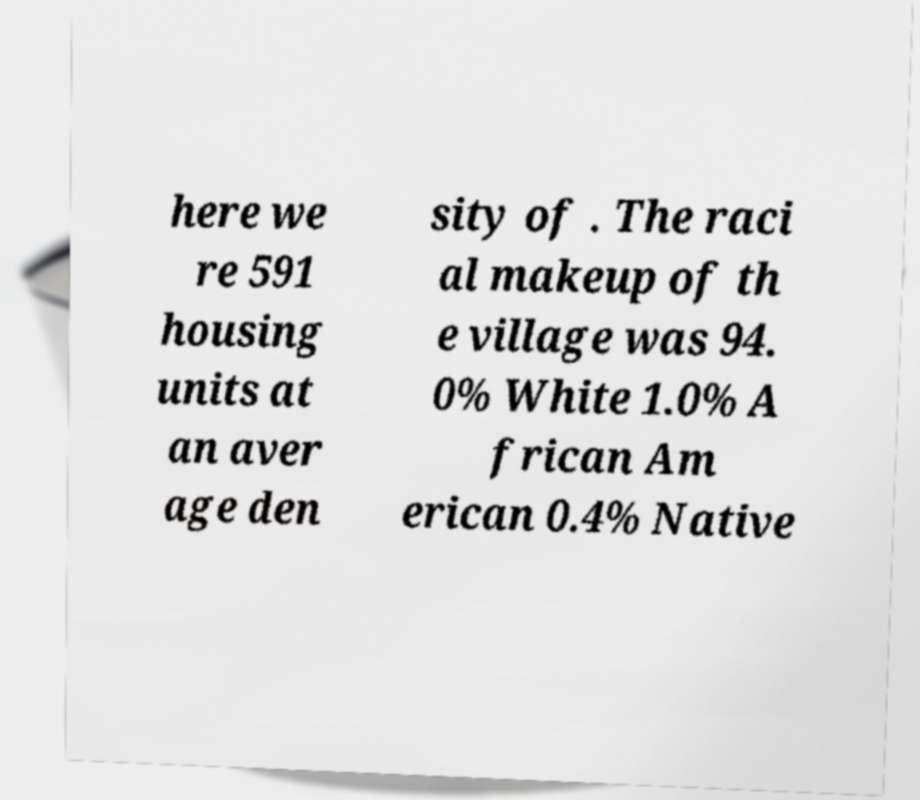Could you extract and type out the text from this image? here we re 591 housing units at an aver age den sity of . The raci al makeup of th e village was 94. 0% White 1.0% A frican Am erican 0.4% Native 